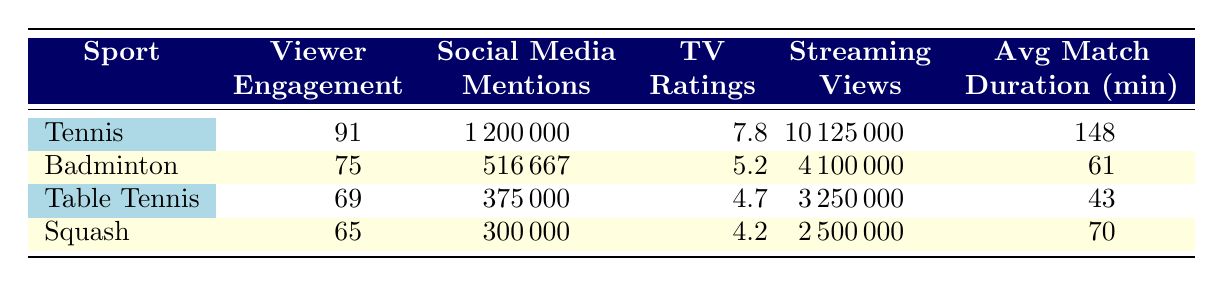What is the average Viewer Engagement for Tennis? To find the average Viewer Engagement for Tennis, we take the values from Wimbledon (95), US Open (92), Australian Open (88), and French Open (90). The sum is (95 + 92 + 88 + 90) = 365, and since there are 4 tournaments, we calculate the average as 365/4 = 91.25, which we can round to 91.
Answer: 91 How many Social Media Mentions does Badminton have in total? For Badminton, we need to add the Social Media Mentions from the All England Open (500000), BWF World Championships (600000), and Thomas Cup (450000). The total is (500000 + 600000 + 450000) = 1550000.
Answer: 1550000 Does Tennis have a higher average TV Rating compared to Squash? Tennis has an average TV Rating of 7.8, while Squash has a TV Rating of 4.2. Since 7.8 is greater than 4.2, we conclude that Tennis does indeed have a higher average TV Rating compared to Squash.
Answer: Yes What is the average match duration of Table Tennis compared to all other racquet sports? The average match duration for Table Tennis is 43 minutes. For Tennis: (150 + 145 + 140 + 155) / 4 = 147.5 minutes. Badminton average is (60 + 65 + 58) / 3 = 61 minutes, and Squash is 70 minutes. Comparing these, we have 43 < 147.5, 43 < 61, and 43 < 70. Therefore, Table Tennis has the shortest average match duration compared to all other racquet sports.
Answer: Shortest Which sport has the highest number of Streaming Views? Referring to the Streaming Views, Tennis has values of 12000000, 10000000, 9000000, and 9500000. The highest is 12000000 from Wimbledon. Badminton has 4000000, 4500000, and 3800000. Table Tennis has 3500000 and 3000000, while Squash has 2500000. Thus, Tennis with 12000000 has the highest Streaming Views among all.
Answer: Tennis What percentage of Streaming Views does Badminton have compared to Tennis? Badminton has total Streaming Views of 4100000, while Tennis has 11000000 (average calculated as the sum of each tournament's views). The percentage is calculated as (4100000 / 11000000) * 100 = 37.27%. Thus, Badminton has approximately 37.27% of the Streaming Views of Tennis.
Answer: 37.27% 